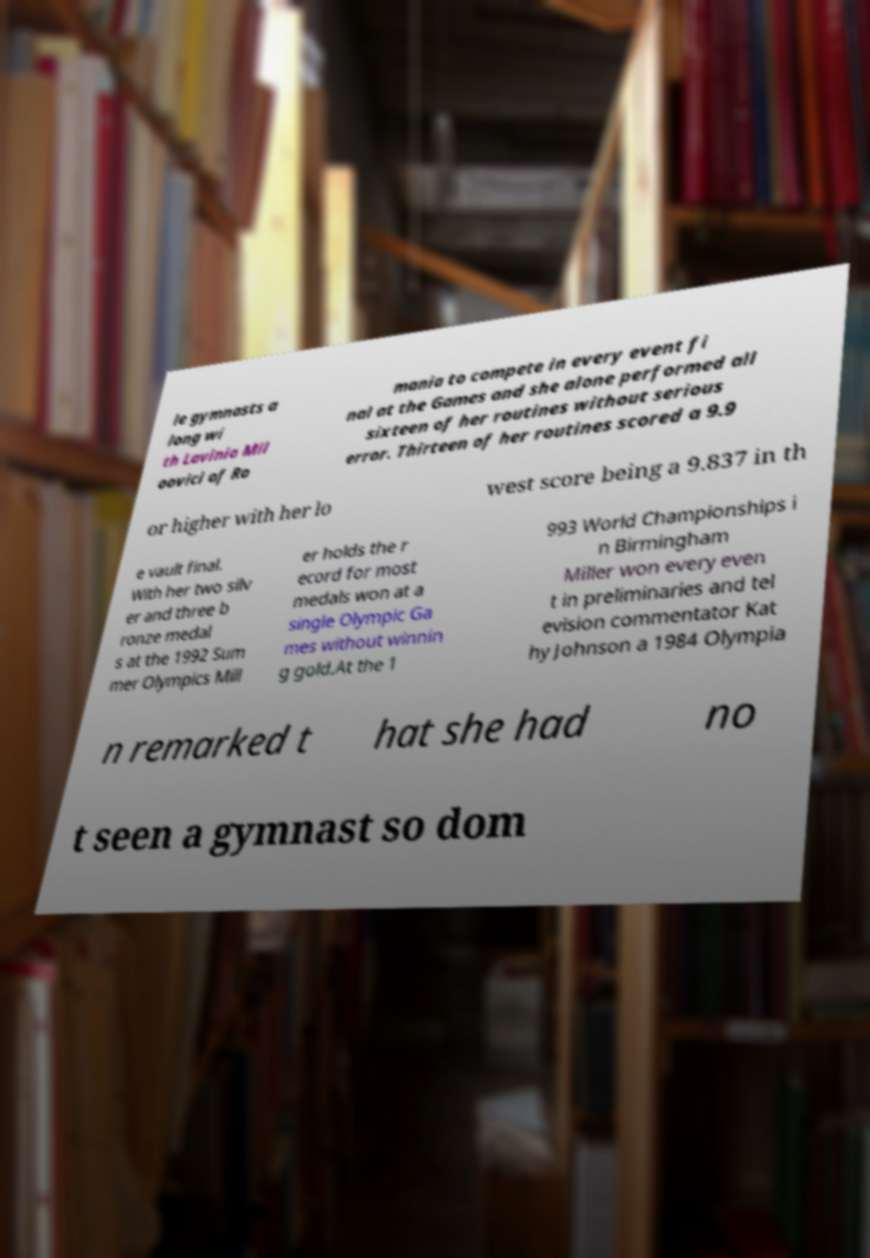For documentation purposes, I need the text within this image transcribed. Could you provide that? le gymnasts a long wi th Lavinia Mil oovici of Ro mania to compete in every event fi nal at the Games and she alone performed all sixteen of her routines without serious error. Thirteen of her routines scored a 9.9 or higher with her lo west score being a 9.837 in th e vault final. With her two silv er and three b ronze medal s at the 1992 Sum mer Olympics Mill er holds the r ecord for most medals won at a single Olympic Ga mes without winnin g gold.At the 1 993 World Championships i n Birmingham Miller won every even t in preliminaries and tel evision commentator Kat hy Johnson a 1984 Olympia n remarked t hat she had no t seen a gymnast so dom 